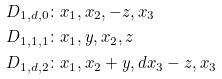Convert formula to latex. <formula><loc_0><loc_0><loc_500><loc_500>D _ { 1 , d , 0 } & \colon x _ { 1 } , x _ { 2 } , - z , x _ { 3 } \\ D _ { 1 , 1 , 1 } & \colon x _ { 1 } , y , x _ { 2 } , z \\ D _ { 1 , d , 2 } & \colon x _ { 1 } , x _ { 2 } + y , d x _ { 3 } - z , x _ { 3 }</formula> 